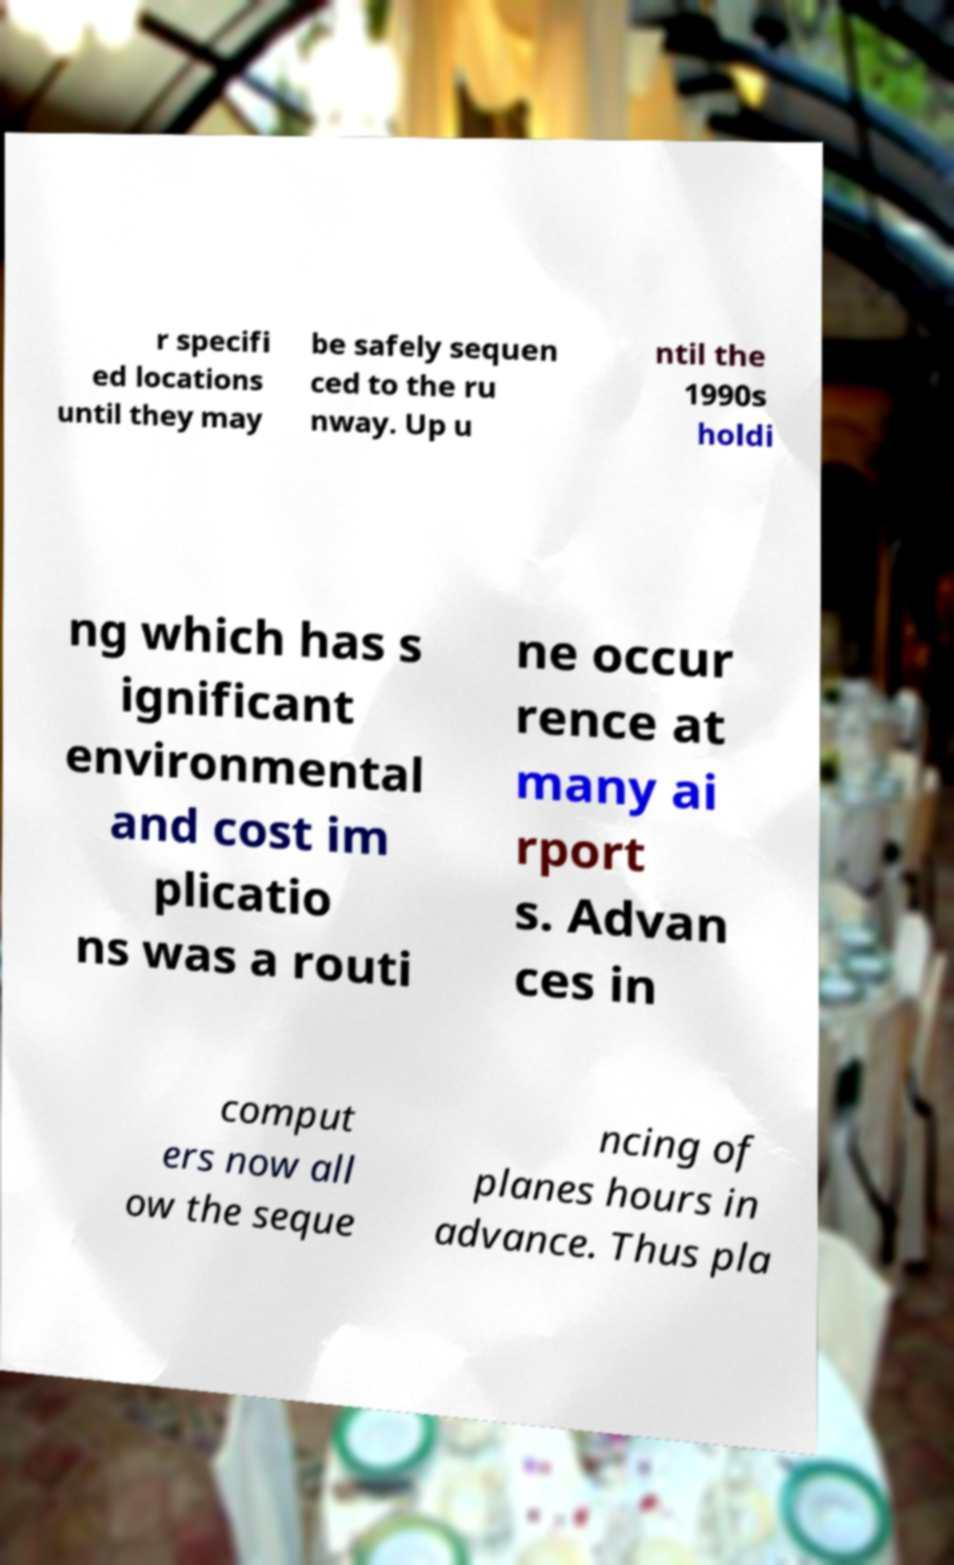There's text embedded in this image that I need extracted. Can you transcribe it verbatim? r specifi ed locations until they may be safely sequen ced to the ru nway. Up u ntil the 1990s holdi ng which has s ignificant environmental and cost im plicatio ns was a routi ne occur rence at many ai rport s. Advan ces in comput ers now all ow the seque ncing of planes hours in advance. Thus pla 